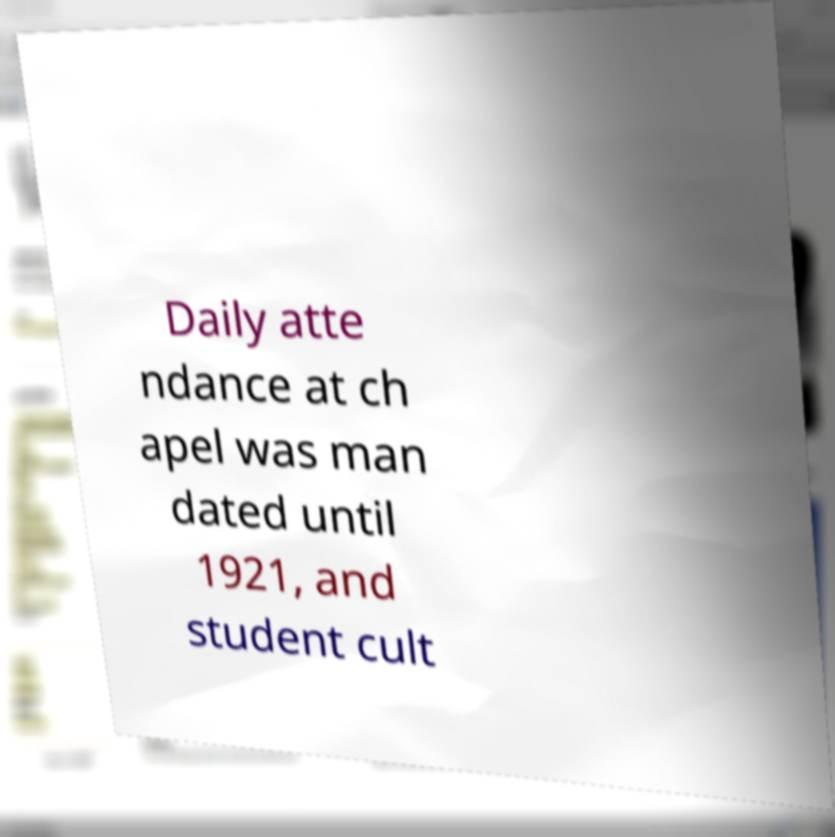Can you read and provide the text displayed in the image?This photo seems to have some interesting text. Can you extract and type it out for me? Daily atte ndance at ch apel was man dated until 1921, and student cult 